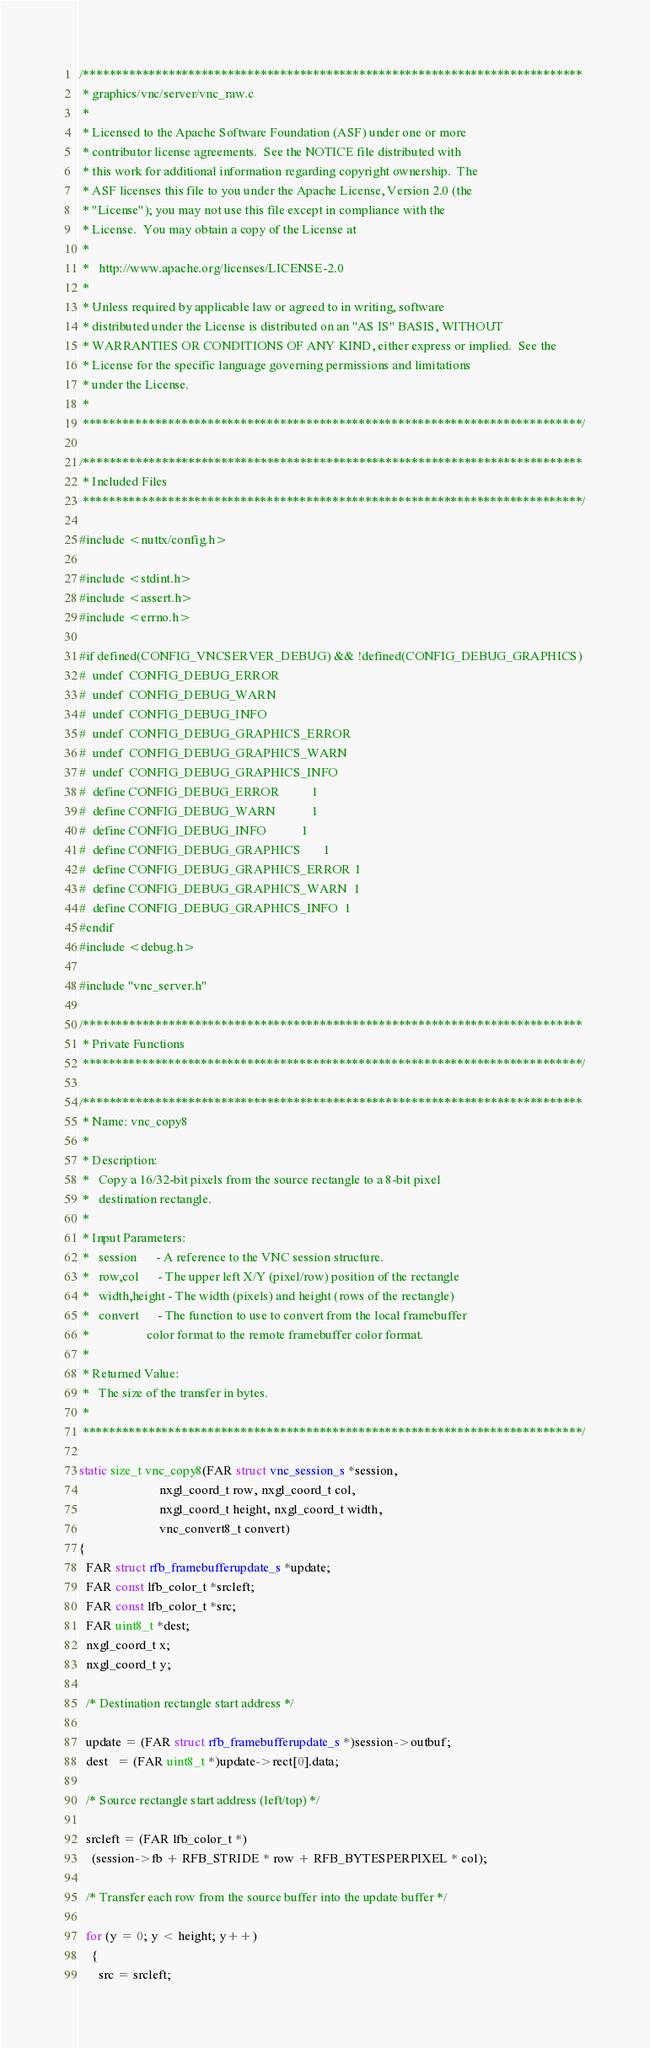<code> <loc_0><loc_0><loc_500><loc_500><_C_>/****************************************************************************
 * graphics/vnc/server/vnc_raw.c
 *
 * Licensed to the Apache Software Foundation (ASF) under one or more
 * contributor license agreements.  See the NOTICE file distributed with
 * this work for additional information regarding copyright ownership.  The
 * ASF licenses this file to you under the Apache License, Version 2.0 (the
 * "License"); you may not use this file except in compliance with the
 * License.  You may obtain a copy of the License at
 *
 *   http://www.apache.org/licenses/LICENSE-2.0
 *
 * Unless required by applicable law or agreed to in writing, software
 * distributed under the License is distributed on an "AS IS" BASIS, WITHOUT
 * WARRANTIES OR CONDITIONS OF ANY KIND, either express or implied.  See the
 * License for the specific language governing permissions and limitations
 * under the License.
 *
 ****************************************************************************/

/****************************************************************************
 * Included Files
 ****************************************************************************/

#include <nuttx/config.h>

#include <stdint.h>
#include <assert.h>
#include <errno.h>

#if defined(CONFIG_VNCSERVER_DEBUG) && !defined(CONFIG_DEBUG_GRAPHICS)
#  undef  CONFIG_DEBUG_ERROR
#  undef  CONFIG_DEBUG_WARN
#  undef  CONFIG_DEBUG_INFO
#  undef  CONFIG_DEBUG_GRAPHICS_ERROR
#  undef  CONFIG_DEBUG_GRAPHICS_WARN
#  undef  CONFIG_DEBUG_GRAPHICS_INFO
#  define CONFIG_DEBUG_ERROR          1
#  define CONFIG_DEBUG_WARN           1
#  define CONFIG_DEBUG_INFO           1
#  define CONFIG_DEBUG_GRAPHICS       1
#  define CONFIG_DEBUG_GRAPHICS_ERROR 1
#  define CONFIG_DEBUG_GRAPHICS_WARN  1
#  define CONFIG_DEBUG_GRAPHICS_INFO  1
#endif
#include <debug.h>

#include "vnc_server.h"

/****************************************************************************
 * Private Functions
 ****************************************************************************/

/****************************************************************************
 * Name: vnc_copy8
 *
 * Description:
 *   Copy a 16/32-bit pixels from the source rectangle to a 8-bit pixel
 *   destination rectangle.
 *
 * Input Parameters:
 *   session      - A reference to the VNC session structure.
 *   row,col      - The upper left X/Y (pixel/row) position of the rectangle
 *   width,height - The width (pixels) and height (rows of the rectangle)
 *   convert      - The function to use to convert from the local framebuffer
 *                  color format to the remote framebuffer color format.
 *
 * Returned Value:
 *   The size of the transfer in bytes.
 *
 ****************************************************************************/

static size_t vnc_copy8(FAR struct vnc_session_s *session,
                         nxgl_coord_t row, nxgl_coord_t col,
                         nxgl_coord_t height, nxgl_coord_t width,
                         vnc_convert8_t convert)
{
  FAR struct rfb_framebufferupdate_s *update;
  FAR const lfb_color_t *srcleft;
  FAR const lfb_color_t *src;
  FAR uint8_t *dest;
  nxgl_coord_t x;
  nxgl_coord_t y;

  /* Destination rectangle start address */

  update = (FAR struct rfb_framebufferupdate_s *)session->outbuf;
  dest   = (FAR uint8_t *)update->rect[0].data;

  /* Source rectangle start address (left/top) */

  srcleft = (FAR lfb_color_t *)
    (session->fb + RFB_STRIDE * row + RFB_BYTESPERPIXEL * col);

  /* Transfer each row from the source buffer into the update buffer */

  for (y = 0; y < height; y++)
    {
      src = srcleft;</code> 